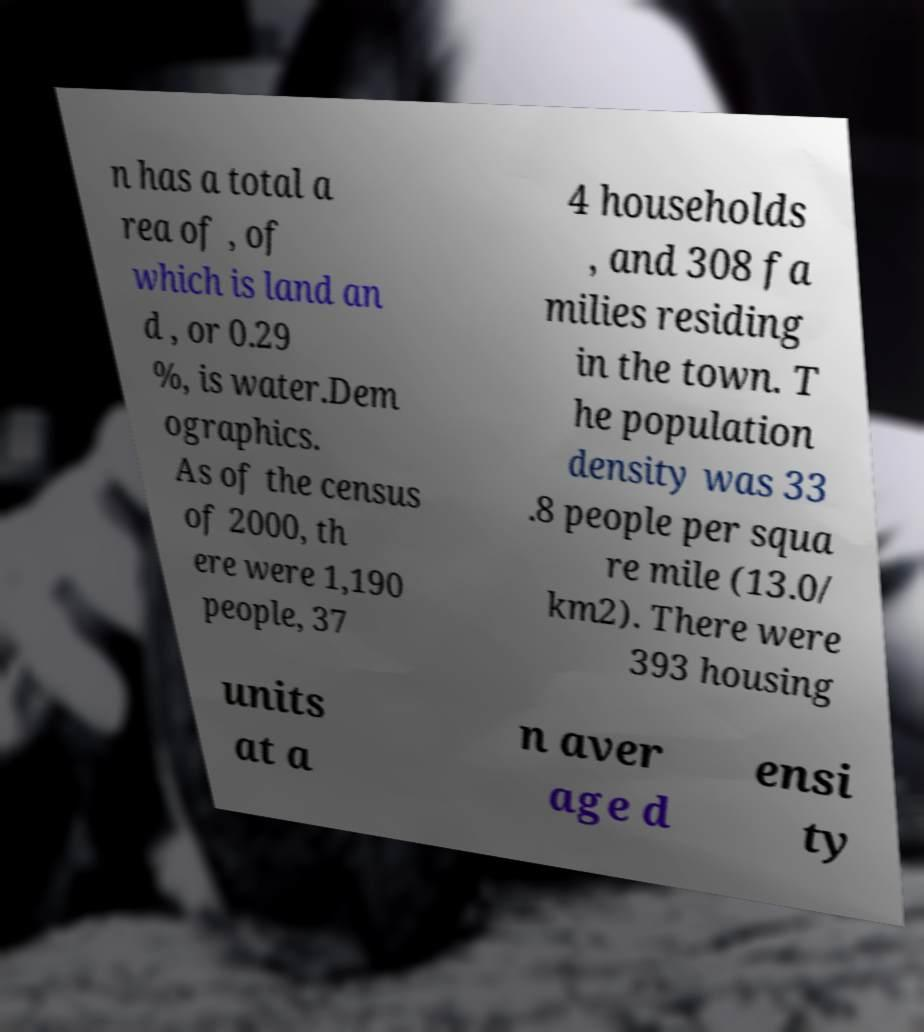Please read and relay the text visible in this image. What does it say? n has a total a rea of , of which is land an d , or 0.29 %, is water.Dem ographics. As of the census of 2000, th ere were 1,190 people, 37 4 households , and 308 fa milies residing in the town. T he population density was 33 .8 people per squa re mile (13.0/ km2). There were 393 housing units at a n aver age d ensi ty 